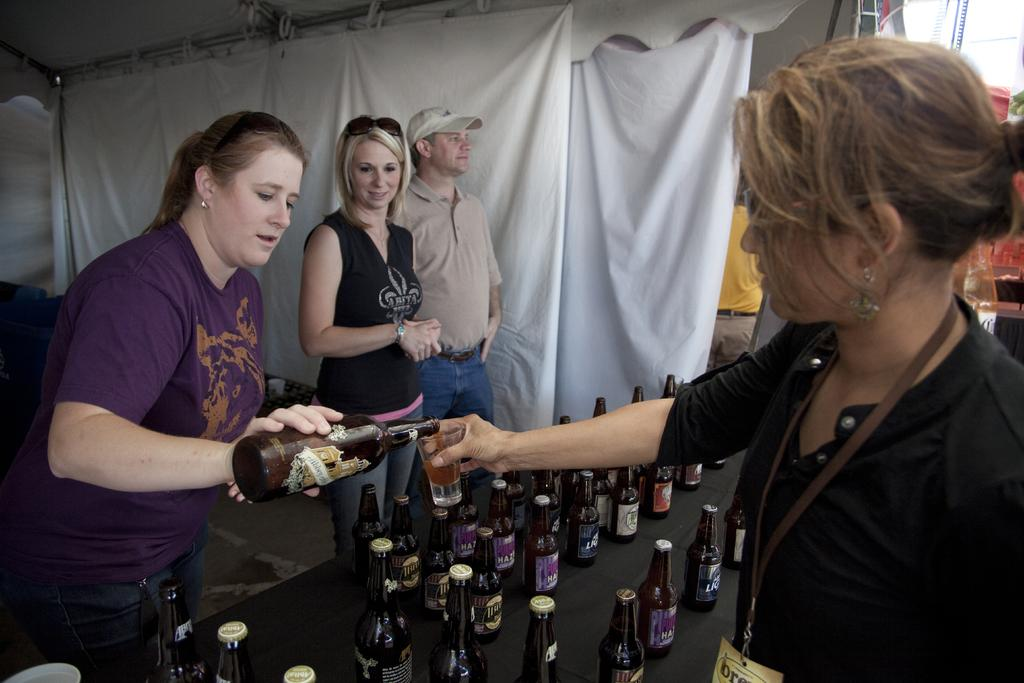What can be seen in the image involving people? There are people standing in the image. What is on the table in the image? There is a table with bottles in the image. What type of material is visible in the image? There is cloth visible in the image. What structures are present at the top of the image? There are poles on the top of the image. What can be seen at the bottom of the image? The ground is visible in the image. How many jellyfish are swimming in the image? There are no jellyfish present in the image. What is the price of the cloth visible in the image? The price of the cloth is not mentioned in the image, as it is not a fact provided. 